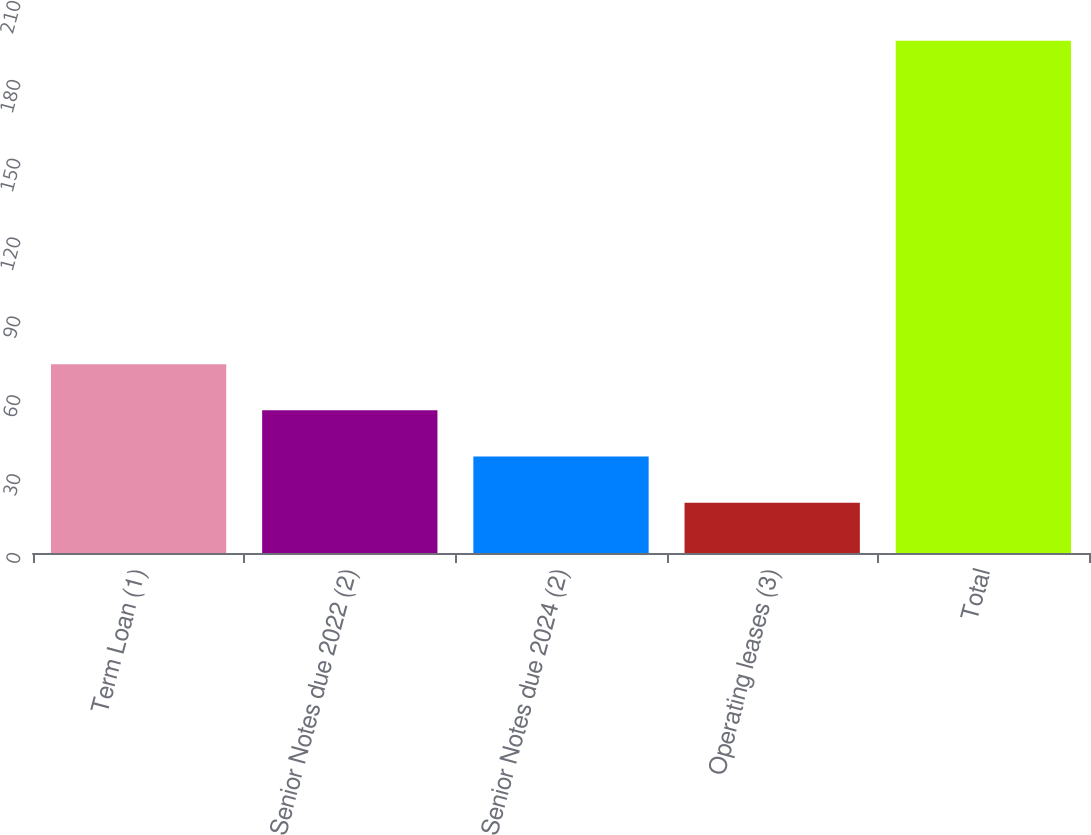Convert chart. <chart><loc_0><loc_0><loc_500><loc_500><bar_chart><fcel>Term Loan (1)<fcel>Senior Notes due 2022 (2)<fcel>Senior Notes due 2024 (2)<fcel>Operating leases (3)<fcel>Total<nl><fcel>71.84<fcel>54.26<fcel>36.68<fcel>19.1<fcel>194.9<nl></chart> 